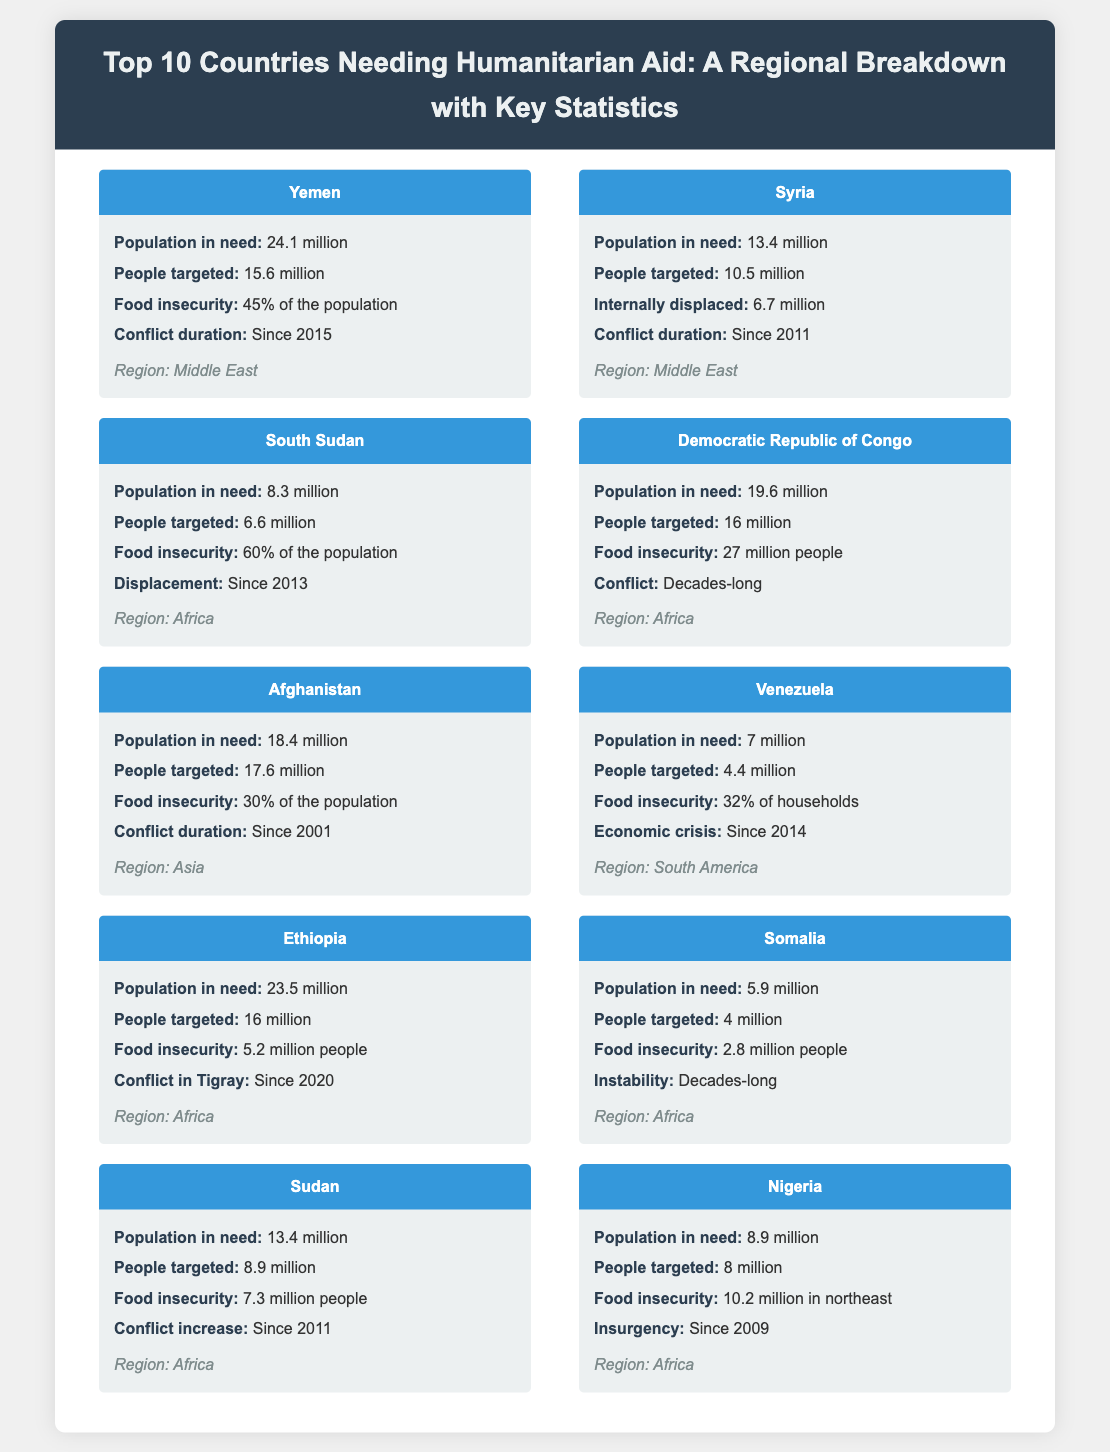What country has the highest population in need? Yemen has the highest population in need, with 24.1 million people.
Answer: Yemen How many people targeted for aid in Syria? Syria has 10.5 million people targeted for aid.
Answer: 10.5 million What is the percentage of food insecurity in South Sudan? In South Sudan, 60% of the population is food insecure.
Answer: 60% What year did the conflict in Afghanistan begin? The conflict in Afghanistan began in 2001.
Answer: 2001 Which region has the highest number of countries listed? Africa has the highest number of countries listed, with four countries.
Answer: Africa Which country has the lowest number of people in need? Somalia has the lowest number of people in need, with 5.9 million.
Answer: Somalia What is the total population in need across all listed countries? To find the total, you would sum all populations in need from the document, which equals 119.1 million.
Answer: 119.1 million What conflict has been ongoing in Ethiopia? The conflict in Tigray has been ongoing since 2020.
Answer: Tigray How long has the conflict in Yemen lasted? The conflict in Yemen has lasted since 2015.
Answer: Since 2015 Which country has the most internally displaced individuals? Syria has the most internally displaced individuals, with 6.7 million.
Answer: 6.7 million 